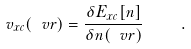Convert formula to latex. <formula><loc_0><loc_0><loc_500><loc_500>v _ { x c } ( \ v r ) = \frac { \delta E _ { x c } [ n ] } { \delta n ( \ v r ) } \quad .</formula> 